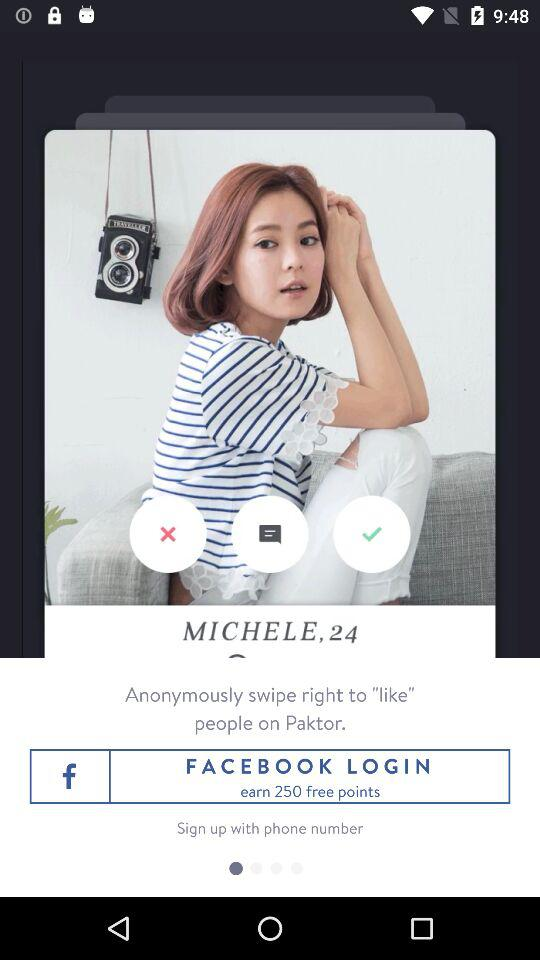How many free points can we earn? You can earn 250 free points. 